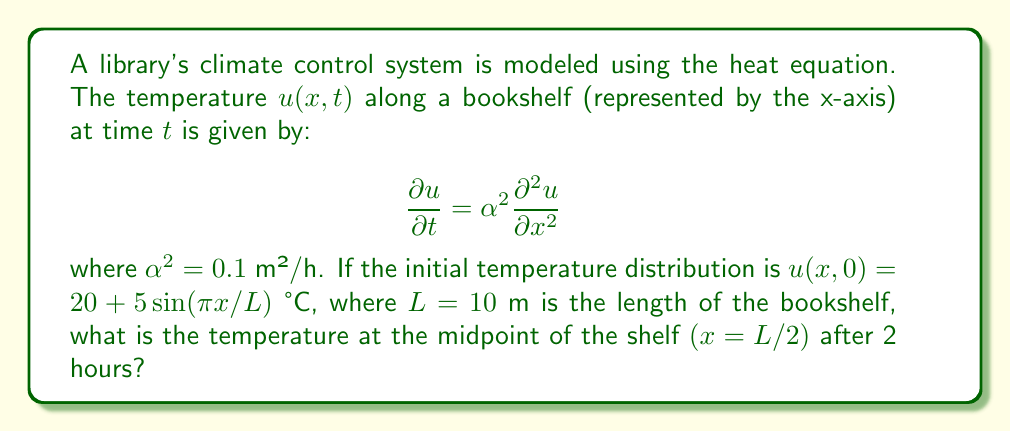Help me with this question. To solve this problem, we'll follow these steps:

1) The general solution to the heat equation with the given initial condition is:

   $$u(x,t) = 20 + 5e^{-\alpha^2(\pi/L)^2t}\sin(\pi x/L)$$

2) We're asked to find the temperature at $x = L/2$ and $t = 2$ hours. Let's substitute these values:

   $$u(L/2, 2) = 20 + 5e^{-0.1(\pi/10)^2 \cdot 2}\sin(\pi \cdot 5/10)$$

3) Let's calculate each part:
   
   $\sin(\pi \cdot 5/10) = \sin(\pi/2) = 1$

   $-0.1(\pi/10)^2 \cdot 2 = -0.1 \cdot (\pi^2/50) \approx -0.1974$

4) Now we can simplify:

   $$u(L/2, 2) = 20 + 5e^{-0.1974} \cdot 1$$

5) Calculate the exponential:

   $$e^{-0.1974} \approx 0.8209$$

6) Final calculation:

   $$u(L/2, 2) = 20 + 5 \cdot 0.8209 = 20 + 4.1045 = 24.1045$$

Thus, the temperature at the midpoint of the shelf after 2 hours is approximately 24.1045 °C.
Answer: 24.1045 °C 